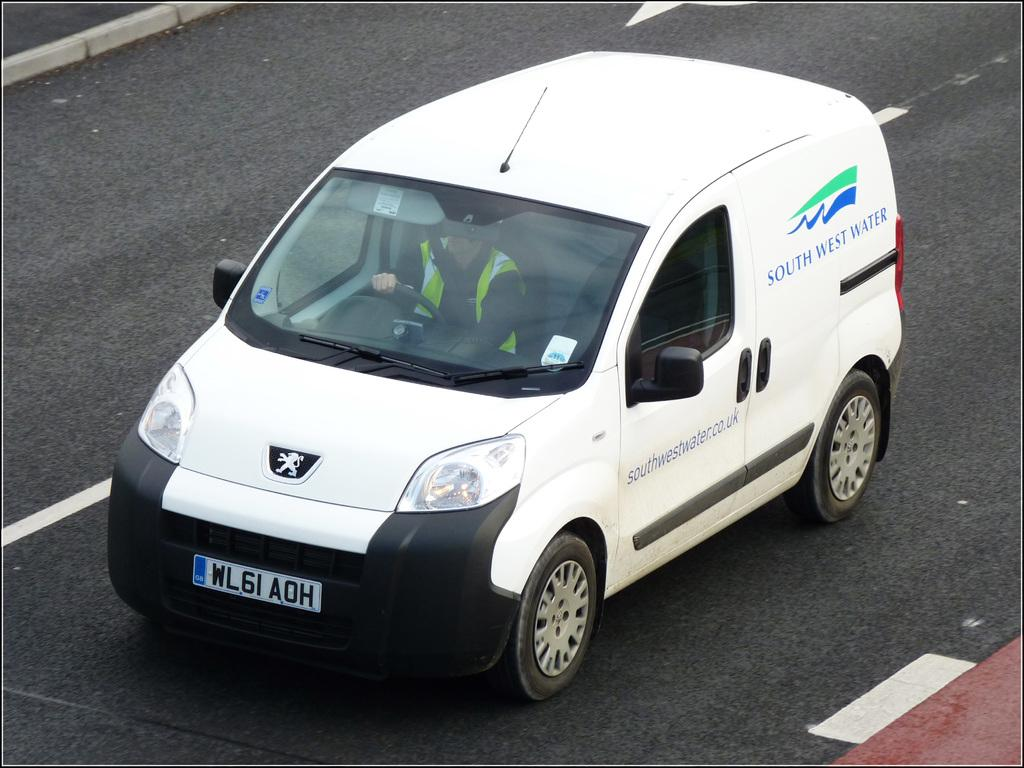<image>
Describe the image concisely. a white South West Water car is on a road 